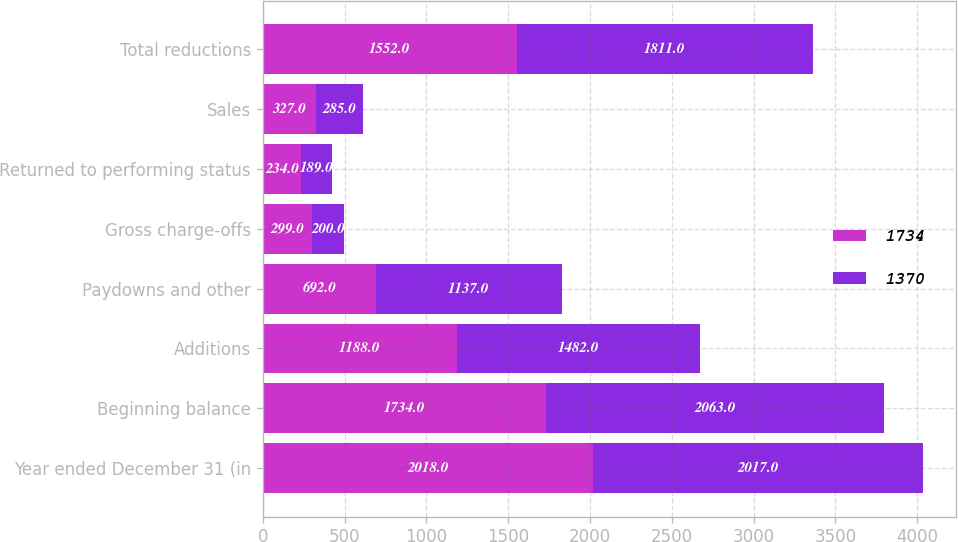Convert chart to OTSL. <chart><loc_0><loc_0><loc_500><loc_500><stacked_bar_chart><ecel><fcel>Year ended December 31 (in<fcel>Beginning balance<fcel>Additions<fcel>Paydowns and other<fcel>Gross charge-offs<fcel>Returned to performing status<fcel>Sales<fcel>Total reductions<nl><fcel>1734<fcel>2018<fcel>1734<fcel>1188<fcel>692<fcel>299<fcel>234<fcel>327<fcel>1552<nl><fcel>1370<fcel>2017<fcel>2063<fcel>1482<fcel>1137<fcel>200<fcel>189<fcel>285<fcel>1811<nl></chart> 